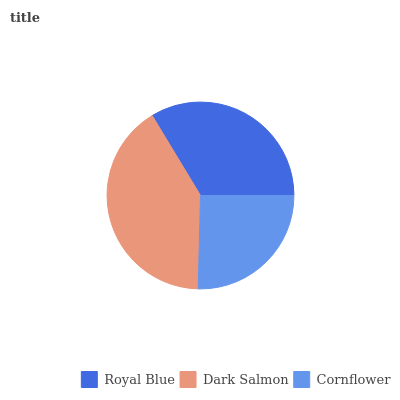Is Cornflower the minimum?
Answer yes or no. Yes. Is Dark Salmon the maximum?
Answer yes or no. Yes. Is Dark Salmon the minimum?
Answer yes or no. No. Is Cornflower the maximum?
Answer yes or no. No. Is Dark Salmon greater than Cornflower?
Answer yes or no. Yes. Is Cornflower less than Dark Salmon?
Answer yes or no. Yes. Is Cornflower greater than Dark Salmon?
Answer yes or no. No. Is Dark Salmon less than Cornflower?
Answer yes or no. No. Is Royal Blue the high median?
Answer yes or no. Yes. Is Royal Blue the low median?
Answer yes or no. Yes. Is Cornflower the high median?
Answer yes or no. No. Is Dark Salmon the low median?
Answer yes or no. No. 